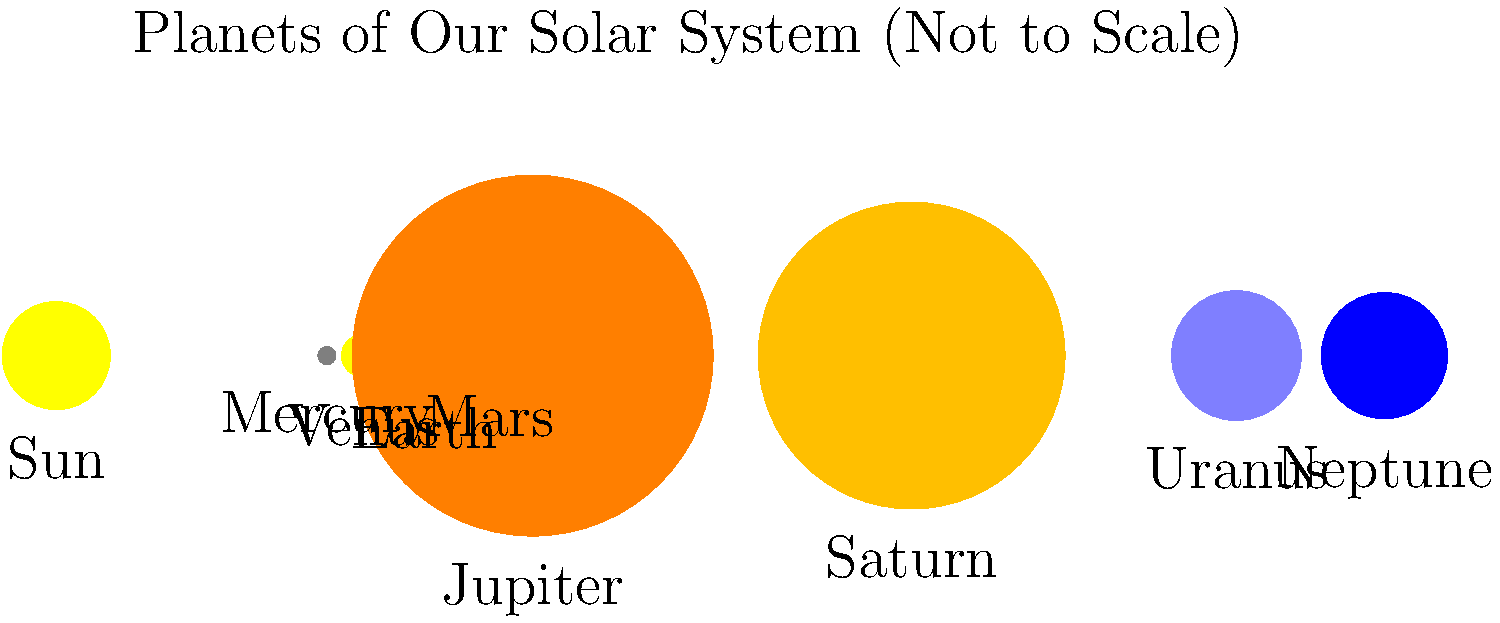In the image above, which planet is represented as the largest, and how does its size compare to that of Earth? Consider this in light of God's creative design of our solar system as mentioned in Genesis 1:16, which states, "God made two great lights—the greater light to govern the day and the lesser light to govern the night. He also made the stars." To answer this question, let's follow these steps:

1. Observe the image: The planets are shown in order from left to right, starting with Mercury and ending with Neptune.

2. Identify the largest planet: Jupiter is clearly depicted as the largest planet in the image.

3. Compare Jupiter to Earth:
   - Jupiter's radius: approximately 69,911 km
   - Earth's radius: approximately 6,371 km
   - Ratio: $\frac{69,911}{6,371} \approx 11$

4. Calculate the volume difference:
   Volume of a sphere = $\frac{4}{3}\pi r^3$
   Ratio of volumes = $(\frac{r_{\text{Jupiter}}}{r_{\text{Earth}}})^3 \approx 11^3 \approx 1,331$

5. Biblical context:
   Genesis 1:16 reminds us that God created all celestial bodies. While the verse specifically mentions the Sun, Moon, and stars, it implies God's role in creating all heavenly bodies, including planets.

6. Reflection on God's design:
   The vast size difference between Jupiter and Earth showcases the diversity and magnitude of God's creation. Jupiter's immense size serves various purposes in our solar system, such as acting as a "cosmic shield" by attracting many asteroids and comets that might otherwise threaten Earth.
Answer: Jupiter; approximately 11 times wider and 1,331 times more voluminous than Earth. 